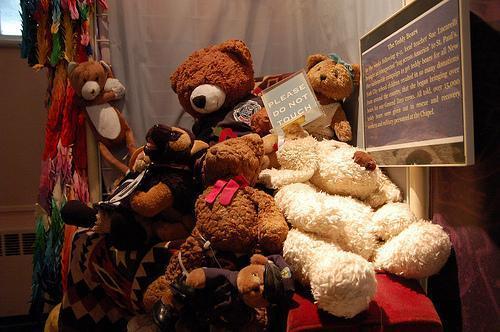How many people playing the toys?
Give a very brief answer. 0. 